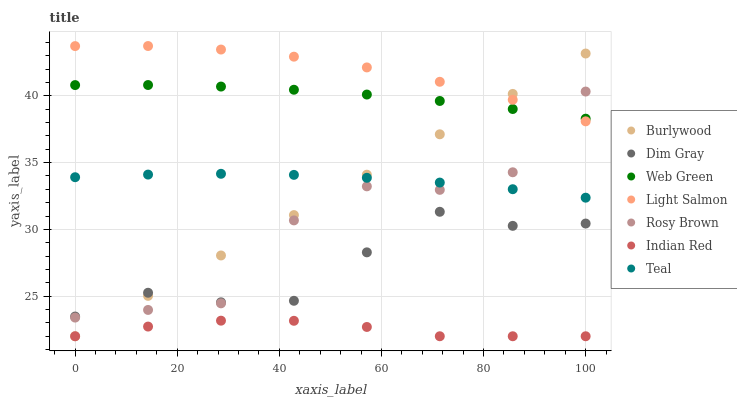Does Indian Red have the minimum area under the curve?
Answer yes or no. Yes. Does Light Salmon have the maximum area under the curve?
Answer yes or no. Yes. Does Dim Gray have the minimum area under the curve?
Answer yes or no. No. Does Dim Gray have the maximum area under the curve?
Answer yes or no. No. Is Burlywood the smoothest?
Answer yes or no. Yes. Is Rosy Brown the roughest?
Answer yes or no. Yes. Is Dim Gray the smoothest?
Answer yes or no. No. Is Dim Gray the roughest?
Answer yes or no. No. Does Burlywood have the lowest value?
Answer yes or no. Yes. Does Dim Gray have the lowest value?
Answer yes or no. No. Does Light Salmon have the highest value?
Answer yes or no. Yes. Does Dim Gray have the highest value?
Answer yes or no. No. Is Indian Red less than Web Green?
Answer yes or no. Yes. Is Web Green greater than Indian Red?
Answer yes or no. Yes. Does Dim Gray intersect Rosy Brown?
Answer yes or no. Yes. Is Dim Gray less than Rosy Brown?
Answer yes or no. No. Is Dim Gray greater than Rosy Brown?
Answer yes or no. No. Does Indian Red intersect Web Green?
Answer yes or no. No. 